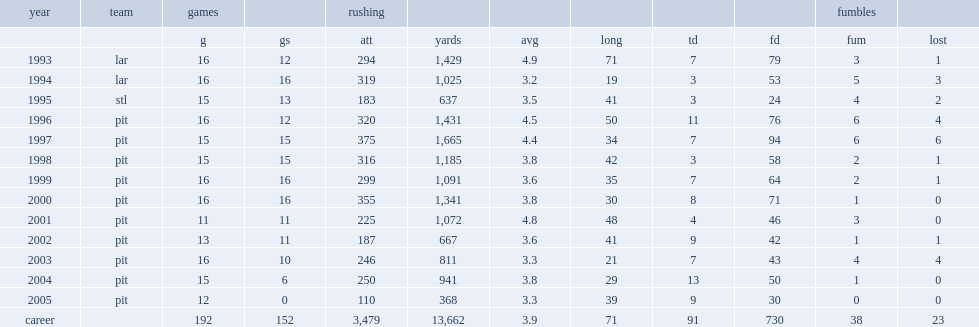How many rushing yards did jerome bettis get in 2001? 1072.0. 